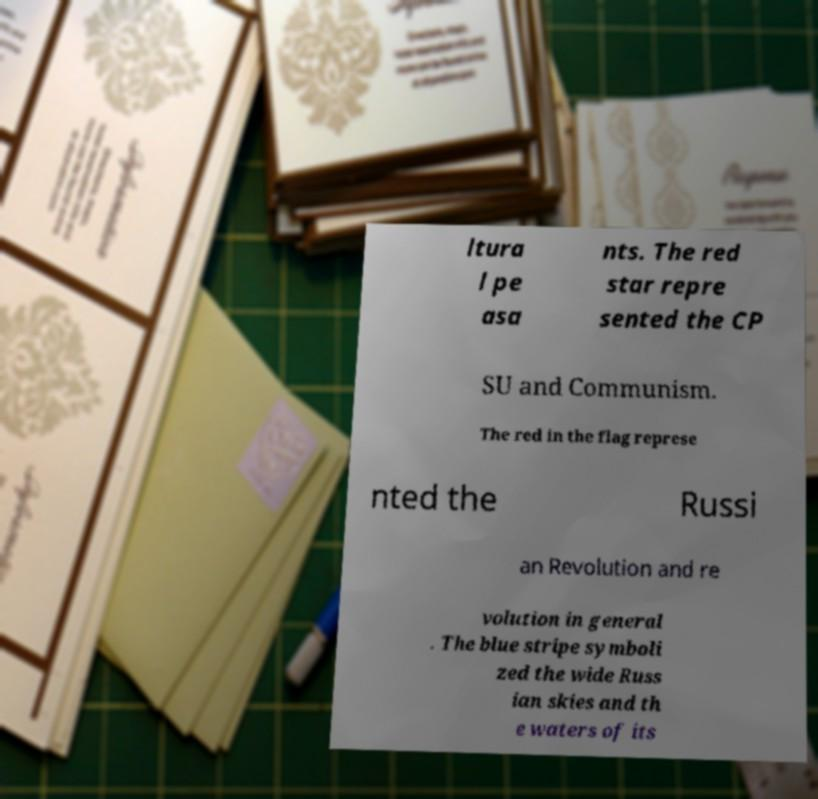Please read and relay the text visible in this image. What does it say? ltura l pe asa nts. The red star repre sented the CP SU and Communism. The red in the flag represe nted the Russi an Revolution and re volution in general . The blue stripe symboli zed the wide Russ ian skies and th e waters of its 